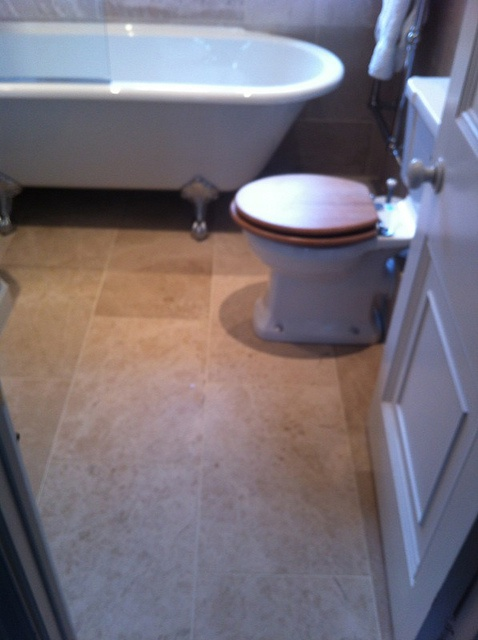Describe the objects in this image and their specific colors. I can see a toilet in gray, white, black, and darkgray tones in this image. 